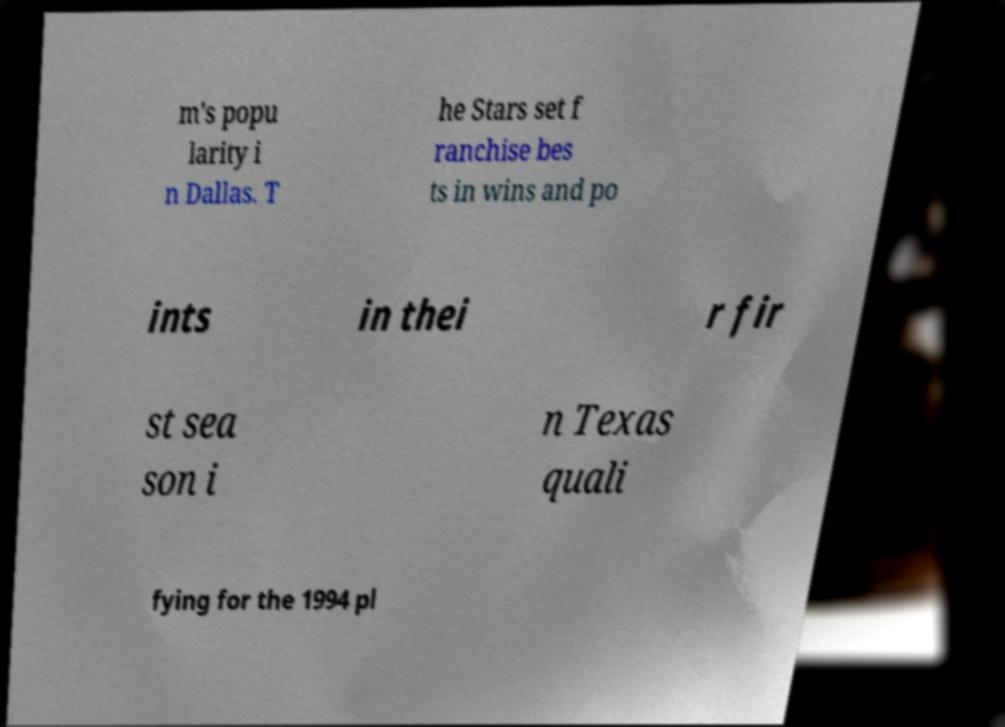What messages or text are displayed in this image? I need them in a readable, typed format. m's popu larity i n Dallas. T he Stars set f ranchise bes ts in wins and po ints in thei r fir st sea son i n Texas quali fying for the 1994 pl 